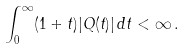Convert formula to latex. <formula><loc_0><loc_0><loc_500><loc_500>\int ^ { \infty } _ { 0 } ( 1 + t ) | Q ( t ) | \, d t < \infty \, .</formula> 